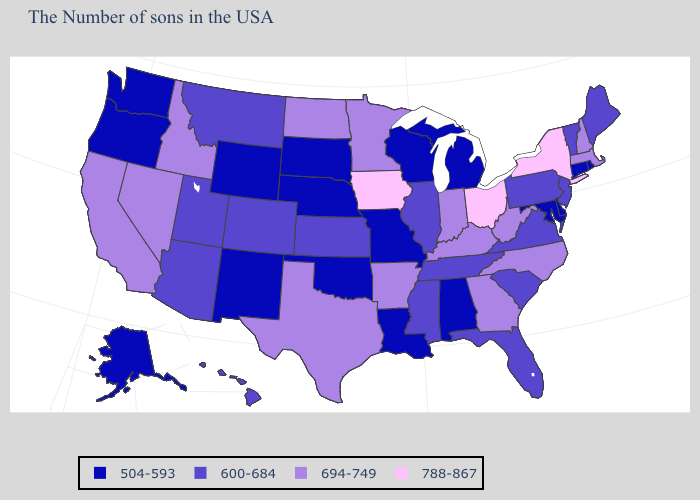Among the states that border Idaho , which have the highest value?
Answer briefly. Nevada. What is the value of Kentucky?
Keep it brief. 694-749. Does Iowa have the highest value in the USA?
Give a very brief answer. Yes. Which states have the highest value in the USA?
Be succinct. New York, Ohio, Iowa. Among the states that border Oregon , does Nevada have the highest value?
Keep it brief. Yes. Does South Dakota have the lowest value in the USA?
Quick response, please. Yes. Which states have the lowest value in the MidWest?
Short answer required. Michigan, Wisconsin, Missouri, Nebraska, South Dakota. Which states have the lowest value in the USA?
Keep it brief. Rhode Island, Connecticut, Delaware, Maryland, Michigan, Alabama, Wisconsin, Louisiana, Missouri, Nebraska, Oklahoma, South Dakota, Wyoming, New Mexico, Washington, Oregon, Alaska. What is the highest value in the USA?
Keep it brief. 788-867. Name the states that have a value in the range 504-593?
Keep it brief. Rhode Island, Connecticut, Delaware, Maryland, Michigan, Alabama, Wisconsin, Louisiana, Missouri, Nebraska, Oklahoma, South Dakota, Wyoming, New Mexico, Washington, Oregon, Alaska. What is the highest value in the USA?
Give a very brief answer. 788-867. How many symbols are there in the legend?
Give a very brief answer. 4. Name the states that have a value in the range 694-749?
Be succinct. Massachusetts, New Hampshire, North Carolina, West Virginia, Georgia, Kentucky, Indiana, Arkansas, Minnesota, Texas, North Dakota, Idaho, Nevada, California. Which states have the lowest value in the Northeast?
Keep it brief. Rhode Island, Connecticut. Which states hav the highest value in the South?
Write a very short answer. North Carolina, West Virginia, Georgia, Kentucky, Arkansas, Texas. 